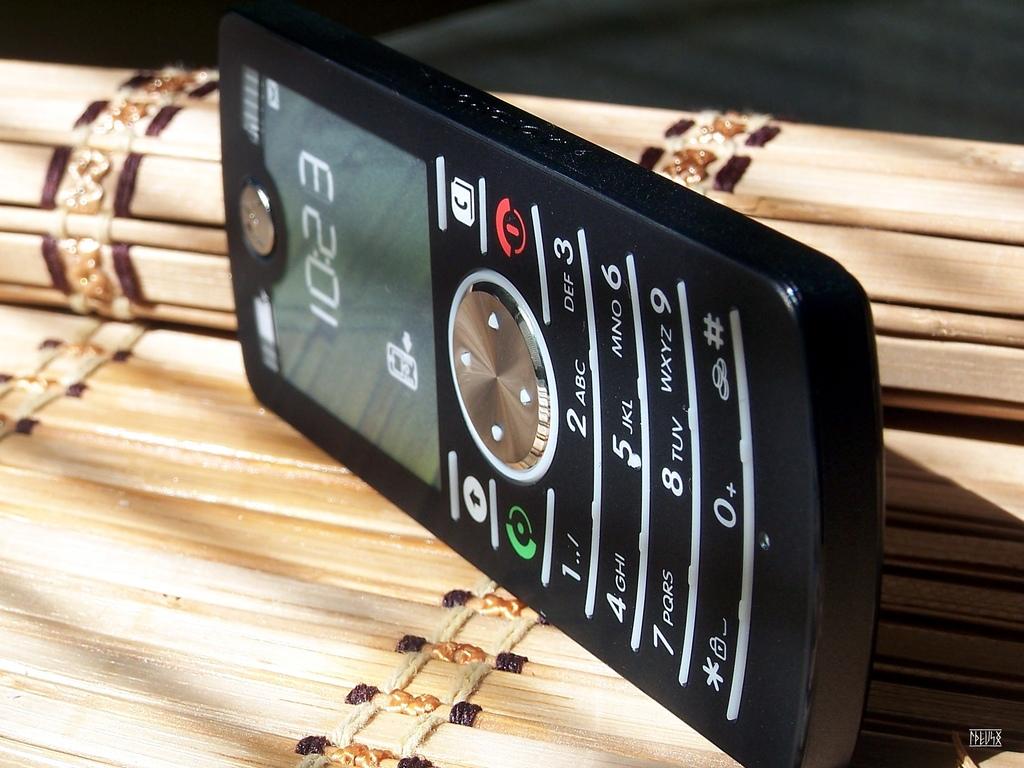What time is shown on the phone?
Give a very brief answer. 10:23. What letters correspond with pressing the 5 key?
Your answer should be compact. Jkl. 